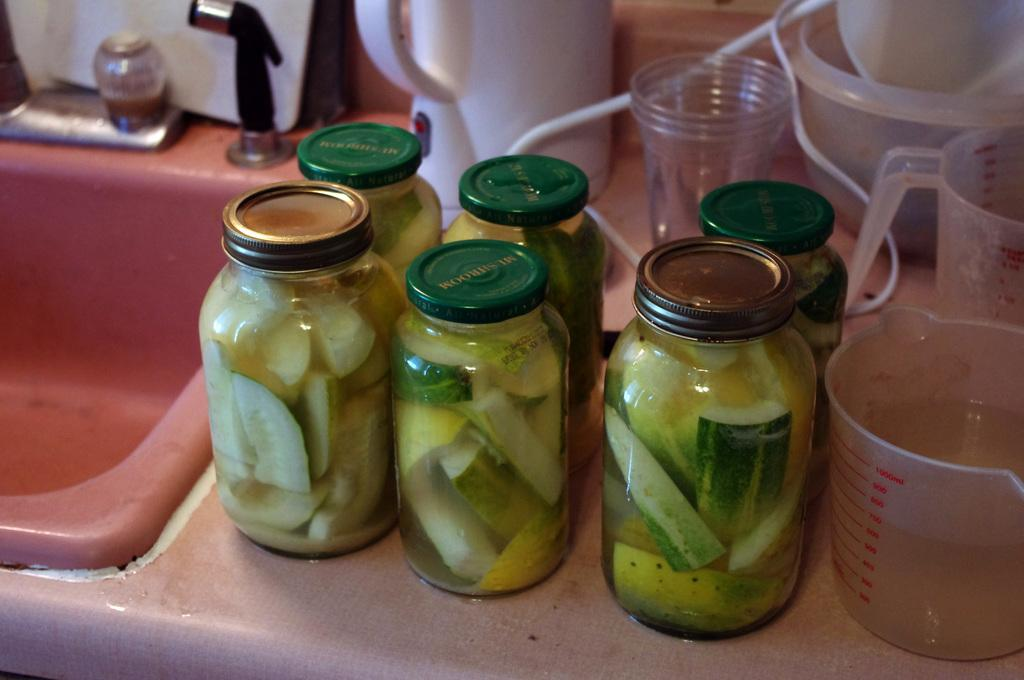What is inside the glass jars in the image? There are glass jars with cucumber pieces in the image. What type of containers are also visible in the image? There are glasses and beakers in the image. What kitchen appliance can be seen in the image? There is a kettle in the image. What is the purpose of the sink with a tap in the image? The sink with a tap in the image is used for washing or filling containers. What type of honey is being produced by the ants in the image? There are no ants or honey present in the image. How does the tongue help in the process of making cucumber pickles in the image? There is no tongue involved in the process of making cucumber pickles in the image. 